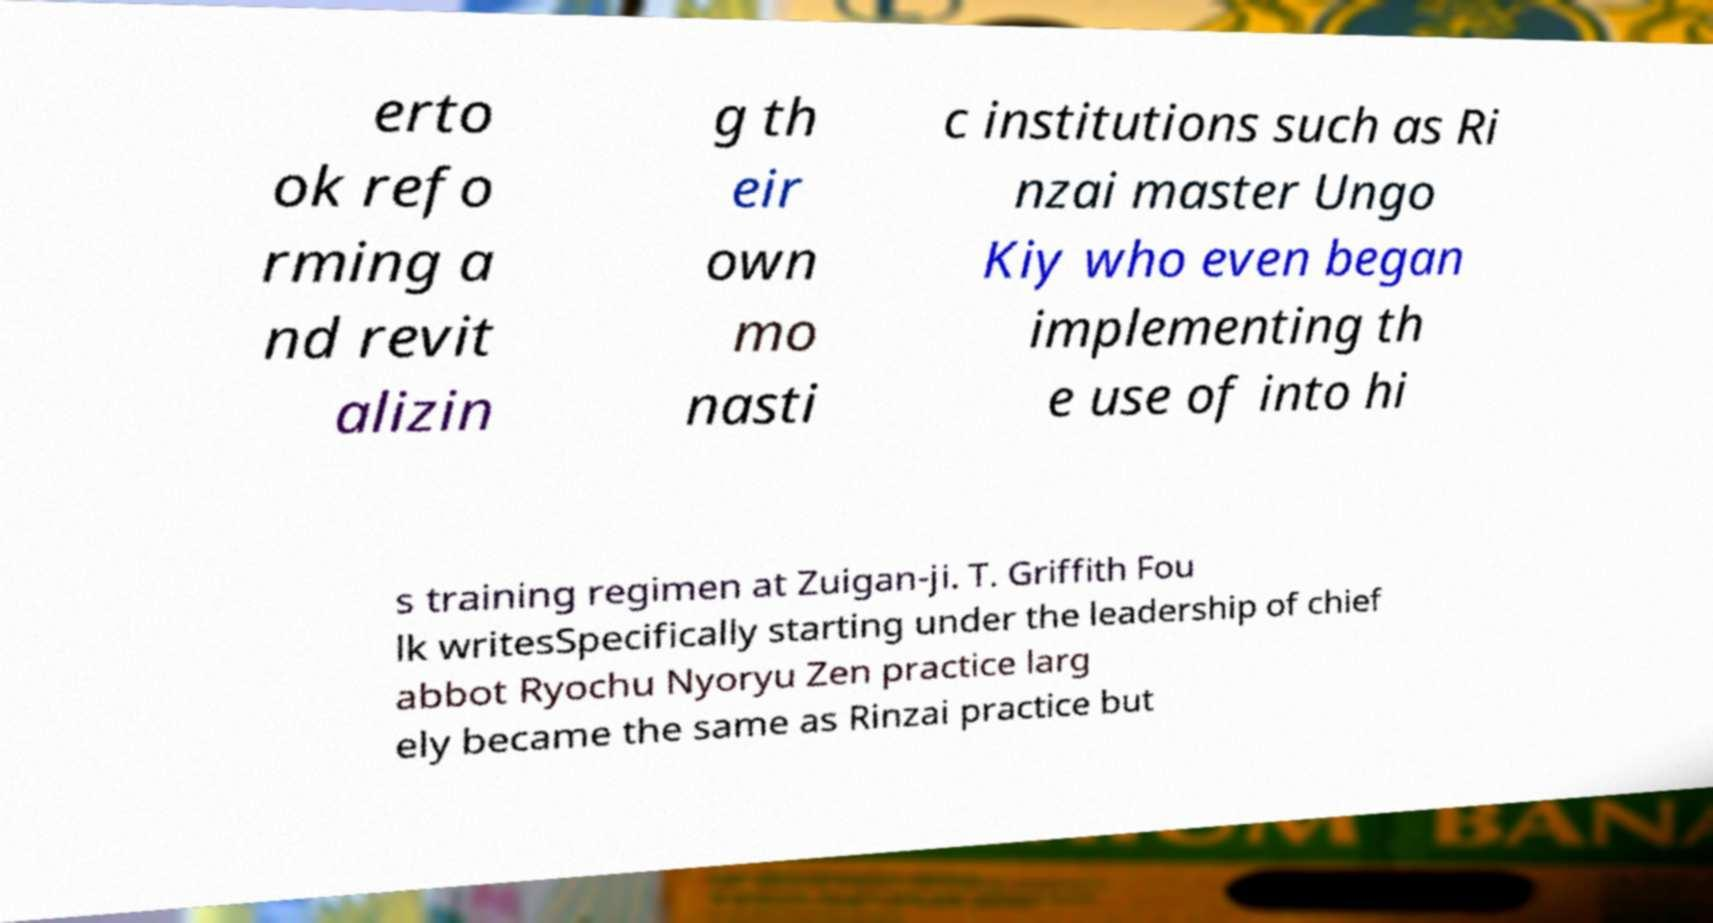I need the written content from this picture converted into text. Can you do that? erto ok refo rming a nd revit alizin g th eir own mo nasti c institutions such as Ri nzai master Ungo Kiy who even began implementing th e use of into hi s training regimen at Zuigan-ji. T. Griffith Fou lk writesSpecifically starting under the leadership of chief abbot Ryochu Nyoryu Zen practice larg ely became the same as Rinzai practice but 